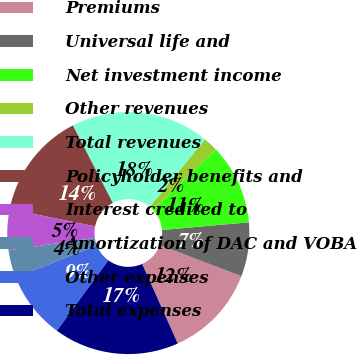Convert chart to OTSL. <chart><loc_0><loc_0><loc_500><loc_500><pie_chart><fcel>Premiums<fcel>Universal life and<fcel>Net investment income<fcel>Other revenues<fcel>Total revenues<fcel>Policyholder benefits and<fcel>Interest credited to<fcel>Amortization of DAC and VOBA<fcel>Other expenses<fcel>Total expenses<nl><fcel>12.5%<fcel>7.22%<fcel>10.74%<fcel>1.93%<fcel>18.49%<fcel>14.26%<fcel>5.46%<fcel>3.69%<fcel>8.98%<fcel>16.73%<nl></chart> 